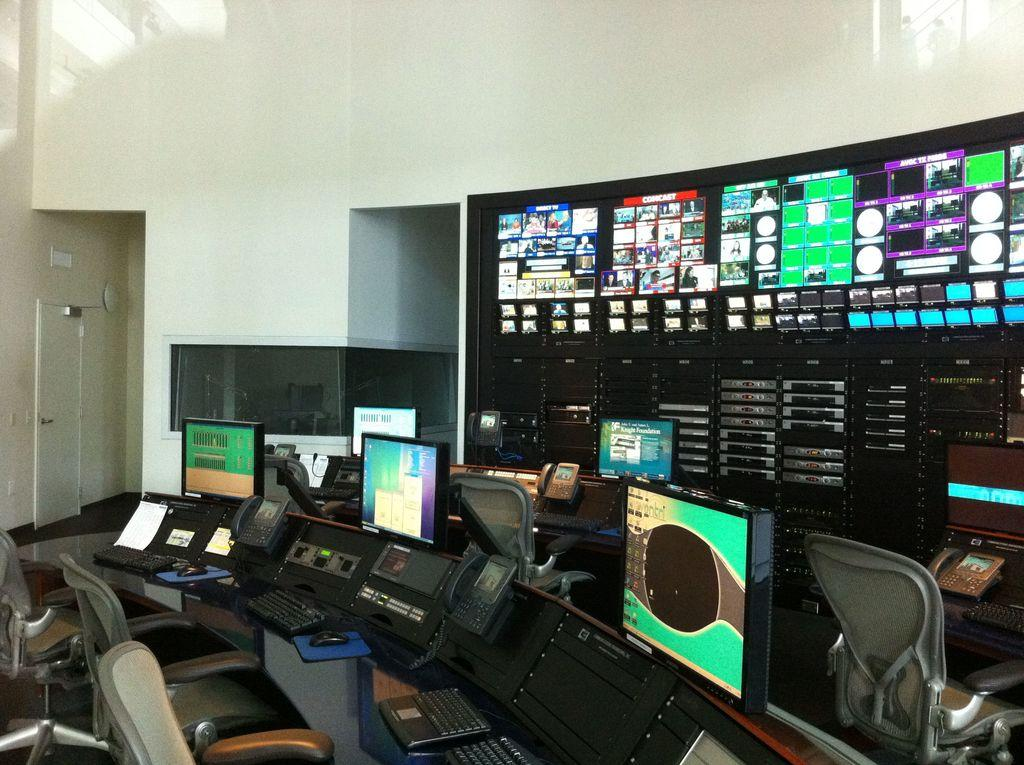What type of furniture is present in the image? There are chairs in the image. What electronic devices can be seen in the image? There are keyboards, telephones, and monitors on the table in the image. What is visible on the table in the image? There are monitors on the table in the image. What type of screen is visible in the image? There is a screen visible in the image. What architectural features can be seen in the background of the image? There are doors and a wall in the background of the image. Is there a bridge visible in the image? No, there is no bridge present in the image. How many visitors can be seen in the image? There is no mention of visitors in the image; it features chairs, keyboards, telephones, monitors, a screen, doors, and a wall. 